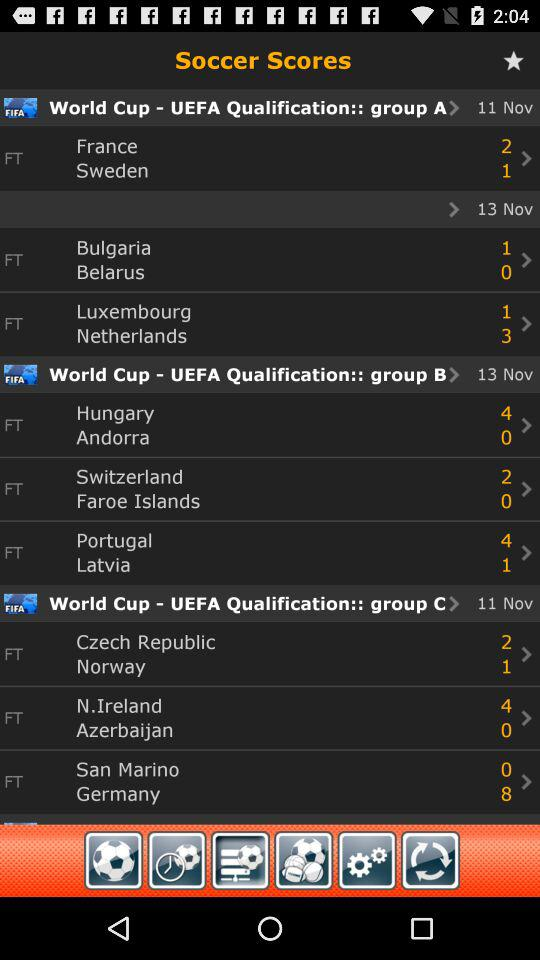When will "France" and "Bulgaria" play?
When the provided information is insufficient, respond with <no answer>. <no answer> 